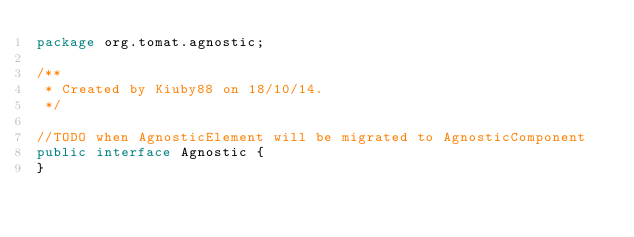Convert code to text. <code><loc_0><loc_0><loc_500><loc_500><_Java_>package org.tomat.agnostic;

/**
 * Created by Kiuby88 on 18/10/14.
 */

//TODO when AgnosticElement will be migrated to AgnosticComponent
public interface Agnostic {
}
</code> 